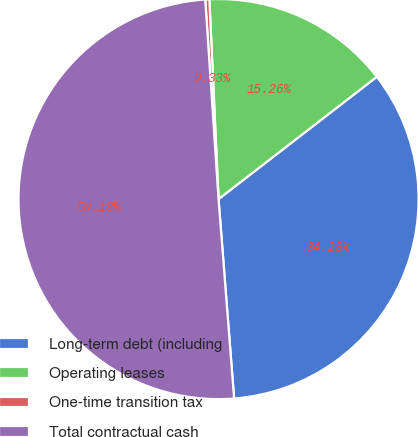<chart> <loc_0><loc_0><loc_500><loc_500><pie_chart><fcel>Long-term debt (including<fcel>Operating leases<fcel>One-time transition tax<fcel>Total contractual cash<nl><fcel>34.23%<fcel>15.26%<fcel>0.33%<fcel>50.18%<nl></chart> 